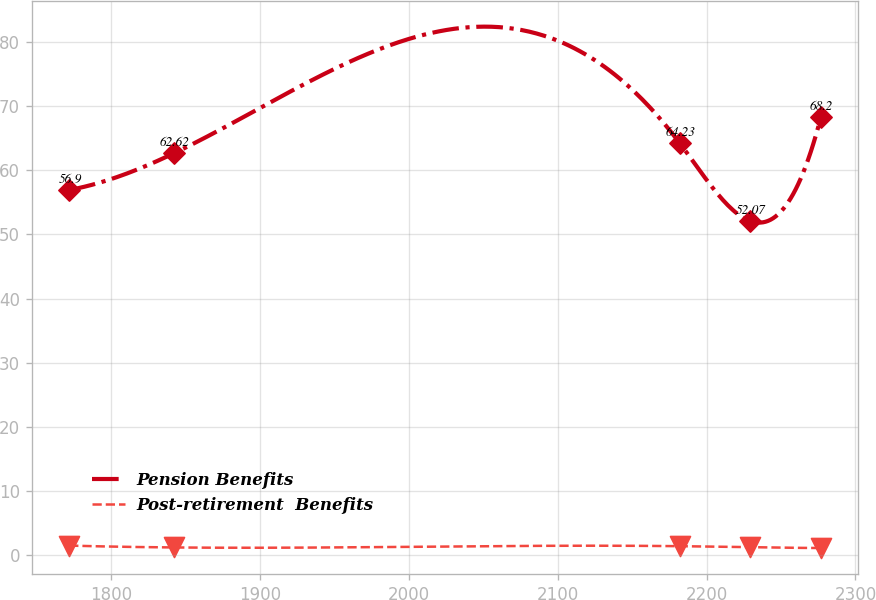<chart> <loc_0><loc_0><loc_500><loc_500><line_chart><ecel><fcel>Pension Benefits<fcel>Post-retirement  Benefits<nl><fcel>1771.94<fcel>56.9<fcel>1.53<nl><fcel>1842.31<fcel>62.62<fcel>1.24<nl><fcel>2181.89<fcel>64.23<fcel>1.44<nl><fcel>2229.32<fcel>52.07<fcel>1.28<nl><fcel>2276.75<fcel>68.2<fcel>1.15<nl></chart> 